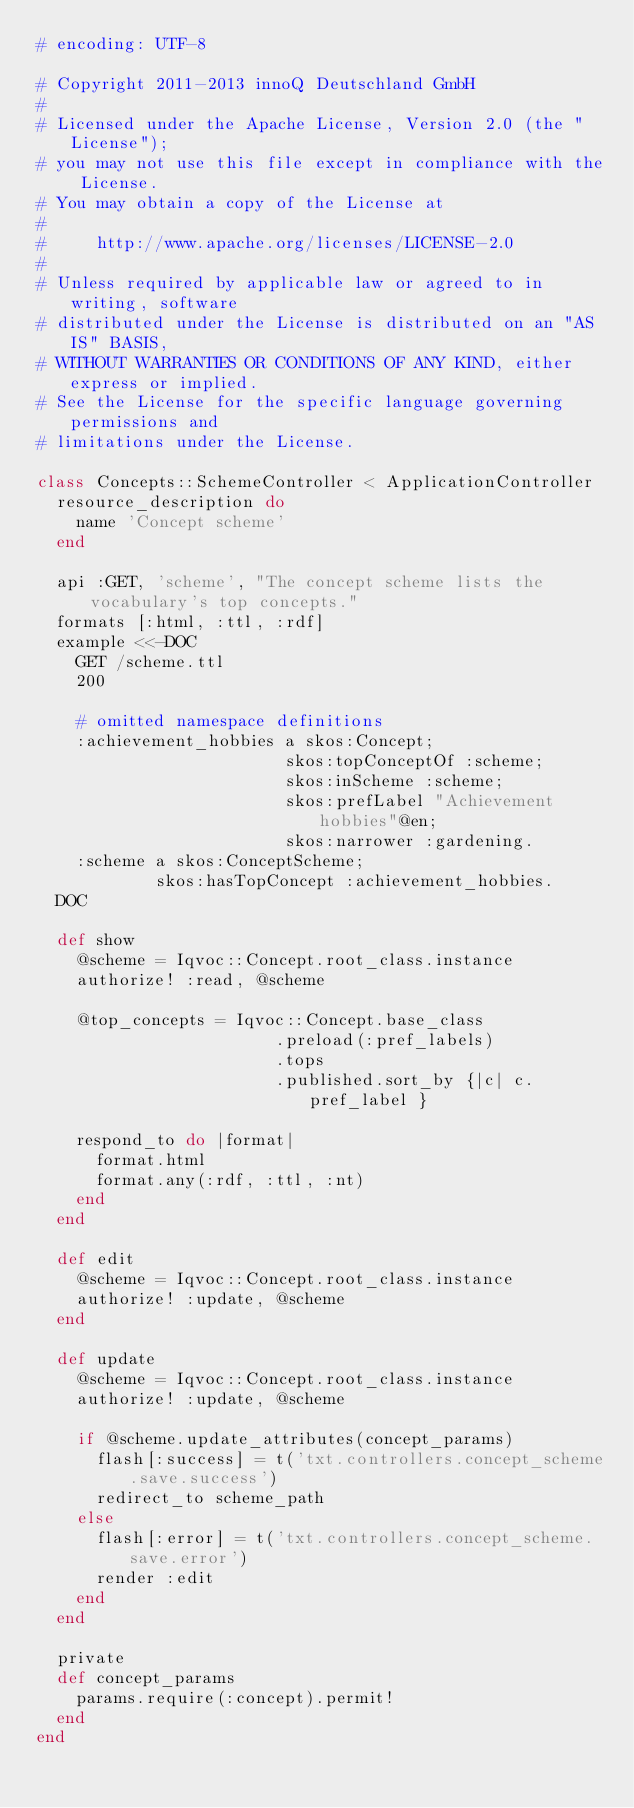Convert code to text. <code><loc_0><loc_0><loc_500><loc_500><_Ruby_># encoding: UTF-8

# Copyright 2011-2013 innoQ Deutschland GmbH
#
# Licensed under the Apache License, Version 2.0 (the "License");
# you may not use this file except in compliance with the License.
# You may obtain a copy of the License at
#
#     http://www.apache.org/licenses/LICENSE-2.0
#
# Unless required by applicable law or agreed to in writing, software
# distributed under the License is distributed on an "AS IS" BASIS,
# WITHOUT WARRANTIES OR CONDITIONS OF ANY KIND, either express or implied.
# See the License for the specific language governing permissions and
# limitations under the License.

class Concepts::SchemeController < ApplicationController
  resource_description do
    name 'Concept scheme'
  end

  api :GET, 'scheme', "The concept scheme lists the vocabulary's top concepts."
  formats [:html, :ttl, :rdf]
  example <<-DOC
    GET /scheme.ttl
    200

    # omitted namespace definitions
    :achievement_hobbies a skos:Concept;
                         skos:topConceptOf :scheme;
                         skos:inScheme :scheme;
                         skos:prefLabel "Achievement hobbies"@en;
                         skos:narrower :gardening.
    :scheme a skos:ConceptScheme;
            skos:hasTopConcept :achievement_hobbies.
  DOC

  def show
    @scheme = Iqvoc::Concept.root_class.instance
    authorize! :read, @scheme

    @top_concepts = Iqvoc::Concept.base_class
                        .preload(:pref_labels)
                        .tops
                        .published.sort_by {|c| c.pref_label }

    respond_to do |format|
      format.html
      format.any(:rdf, :ttl, :nt)
    end
  end

  def edit
    @scheme = Iqvoc::Concept.root_class.instance
    authorize! :update, @scheme
  end

  def update
    @scheme = Iqvoc::Concept.root_class.instance
    authorize! :update, @scheme

    if @scheme.update_attributes(concept_params)
      flash[:success] = t('txt.controllers.concept_scheme.save.success')
      redirect_to scheme_path
    else
      flash[:error] = t('txt.controllers.concept_scheme.save.error')
      render :edit
    end
  end

  private
  def concept_params
    params.require(:concept).permit!
  end
end
</code> 